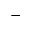<formula> <loc_0><loc_0><loc_500><loc_500>^ { - }</formula> 